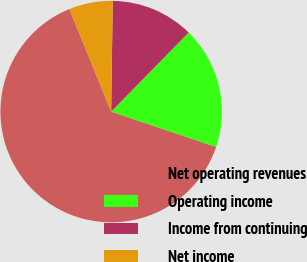Convert chart. <chart><loc_0><loc_0><loc_500><loc_500><pie_chart><fcel>Net operating revenues<fcel>Operating income<fcel>Income from continuing<fcel>Net income<nl><fcel>63.66%<fcel>17.84%<fcel>12.11%<fcel>6.39%<nl></chart> 